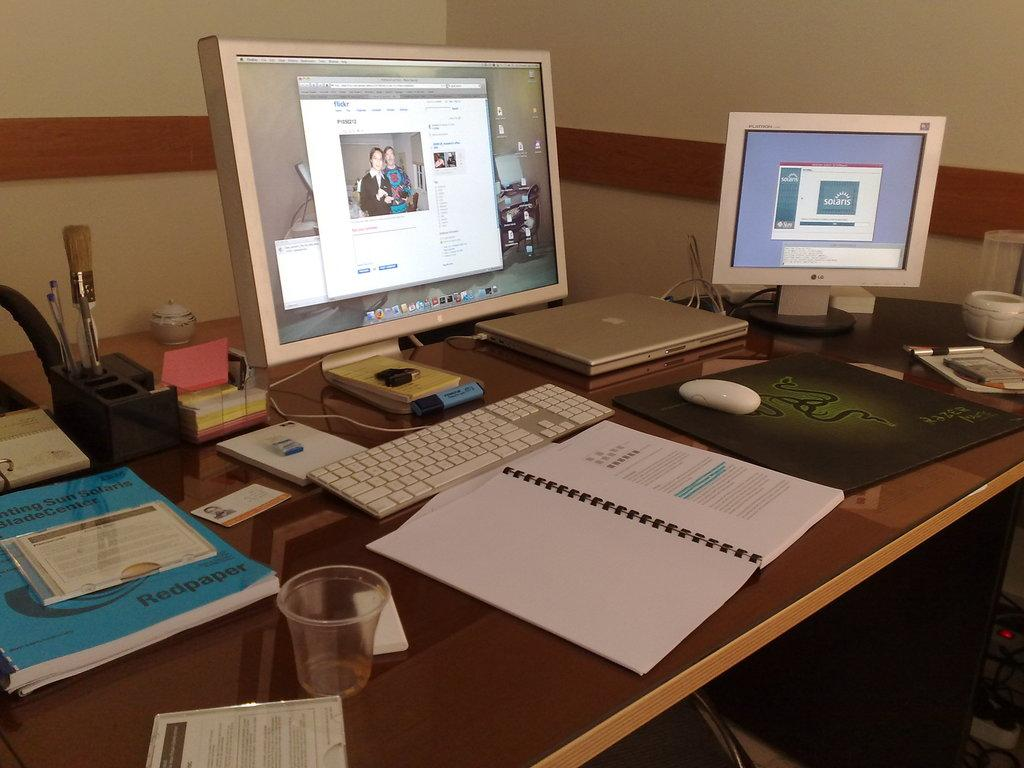What type of furniture is present in the image? There is a table in the image. What electronic devices are on the table? There are monitors, a laptop, a keyboard, a mouse, and a CPU on the table. What can be used for writing in the image? There are pens on the table. What is used for holding liquids in the image? There is a glass on the table. What type of paperwork is present in the image? There are files on the table. What is the background of the image? There is a wall in the background of the image. What type of minister is present in the image? There is no minister present in the image. What caption is written on the glass in the image? There is no caption written on the glass in the image. 